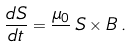Convert formula to latex. <formula><loc_0><loc_0><loc_500><loc_500>\frac { d { S } } { d t } = \frac { \mu _ { 0 } } { } \, { S } \times { B } \, .</formula> 